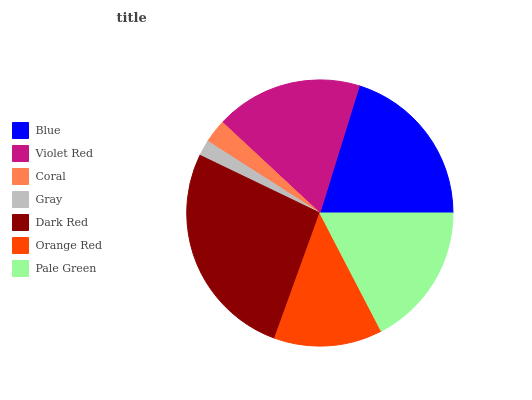Is Gray the minimum?
Answer yes or no. Yes. Is Dark Red the maximum?
Answer yes or no. Yes. Is Violet Red the minimum?
Answer yes or no. No. Is Violet Red the maximum?
Answer yes or no. No. Is Blue greater than Violet Red?
Answer yes or no. Yes. Is Violet Red less than Blue?
Answer yes or no. Yes. Is Violet Red greater than Blue?
Answer yes or no. No. Is Blue less than Violet Red?
Answer yes or no. No. Is Pale Green the high median?
Answer yes or no. Yes. Is Pale Green the low median?
Answer yes or no. Yes. Is Dark Red the high median?
Answer yes or no. No. Is Coral the low median?
Answer yes or no. No. 